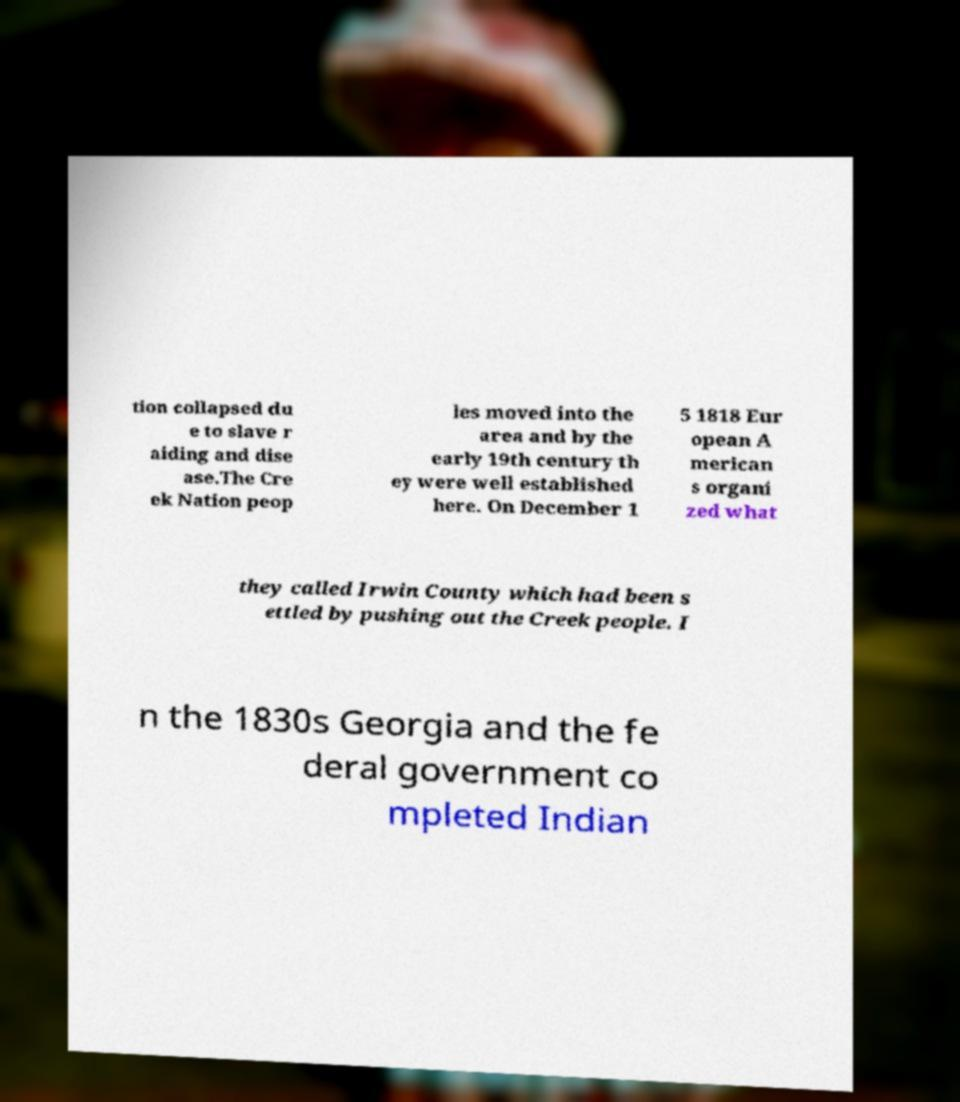Please read and relay the text visible in this image. What does it say? tion collapsed du e to slave r aiding and dise ase.The Cre ek Nation peop les moved into the area and by the early 19th century th ey were well established here. On December 1 5 1818 Eur opean A merican s organi zed what they called Irwin County which had been s ettled by pushing out the Creek people. I n the 1830s Georgia and the fe deral government co mpleted Indian 